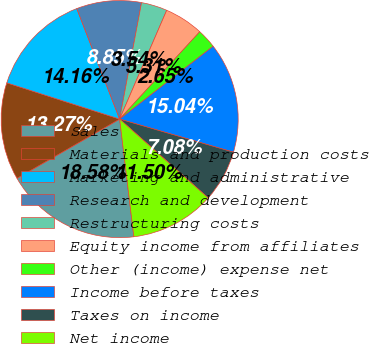Convert chart. <chart><loc_0><loc_0><loc_500><loc_500><pie_chart><fcel>Sales<fcel>Materials and production costs<fcel>Marketing and administrative<fcel>Research and development<fcel>Restructuring costs<fcel>Equity income from affiliates<fcel>Other (income) expense net<fcel>Income before taxes<fcel>Taxes on income<fcel>Net income<nl><fcel>18.58%<fcel>13.27%<fcel>14.16%<fcel>8.85%<fcel>3.54%<fcel>5.31%<fcel>2.65%<fcel>15.04%<fcel>7.08%<fcel>11.5%<nl></chart> 